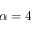Convert formula to latex. <formula><loc_0><loc_0><loc_500><loc_500>\alpha = 4</formula> 